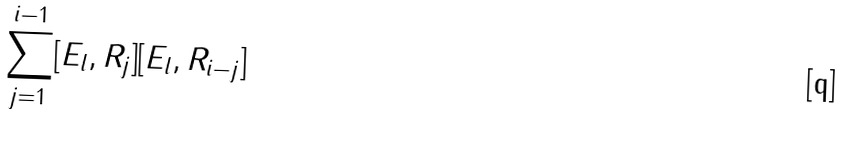<formula> <loc_0><loc_0><loc_500><loc_500>\sum _ { j = 1 } ^ { i - 1 } [ E _ { l } , R _ { j } ] [ E _ { l } , R _ { i - j } ]</formula> 